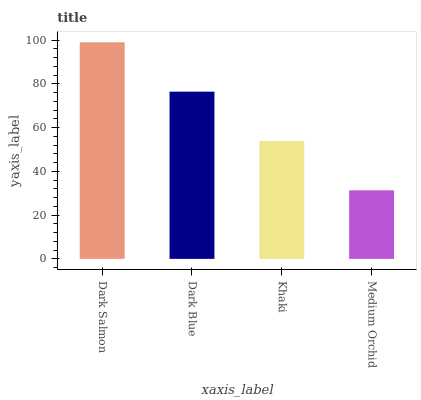Is Dark Blue the minimum?
Answer yes or no. No. Is Dark Blue the maximum?
Answer yes or no. No. Is Dark Salmon greater than Dark Blue?
Answer yes or no. Yes. Is Dark Blue less than Dark Salmon?
Answer yes or no. Yes. Is Dark Blue greater than Dark Salmon?
Answer yes or no. No. Is Dark Salmon less than Dark Blue?
Answer yes or no. No. Is Dark Blue the high median?
Answer yes or no. Yes. Is Khaki the low median?
Answer yes or no. Yes. Is Khaki the high median?
Answer yes or no. No. Is Dark Salmon the low median?
Answer yes or no. No. 